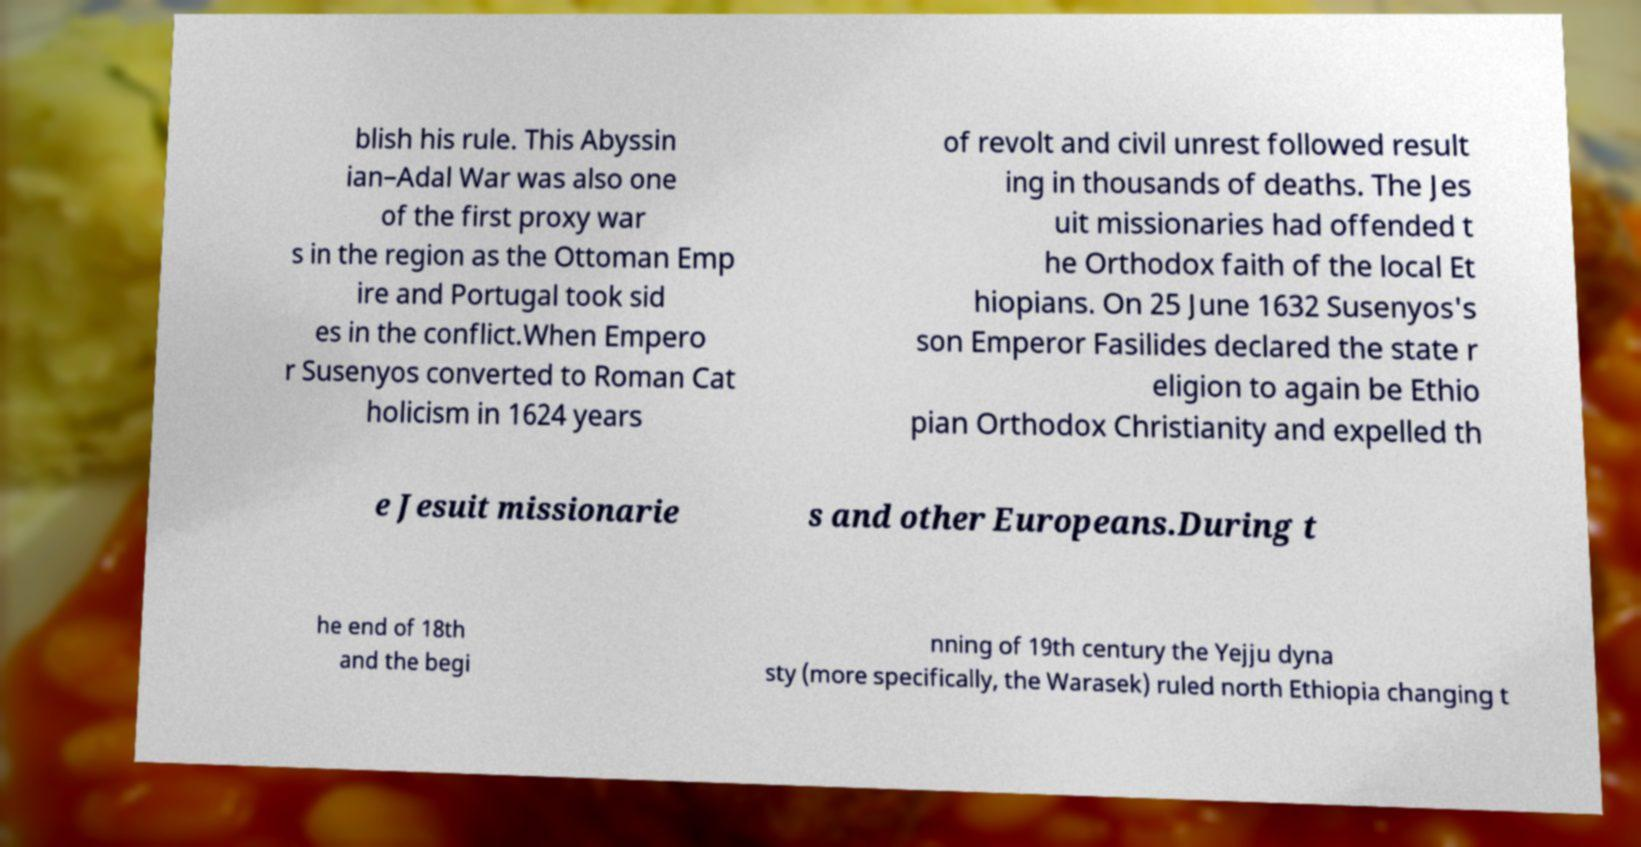What messages or text are displayed in this image? I need them in a readable, typed format. blish his rule. This Abyssin ian–Adal War was also one of the first proxy war s in the region as the Ottoman Emp ire and Portugal took sid es in the conflict.When Empero r Susenyos converted to Roman Cat holicism in 1624 years of revolt and civil unrest followed result ing in thousands of deaths. The Jes uit missionaries had offended t he Orthodox faith of the local Et hiopians. On 25 June 1632 Susenyos's son Emperor Fasilides declared the state r eligion to again be Ethio pian Orthodox Christianity and expelled th e Jesuit missionarie s and other Europeans.During t he end of 18th and the begi nning of 19th century the Yejju dyna sty (more specifically, the Warasek) ruled north Ethiopia changing t 